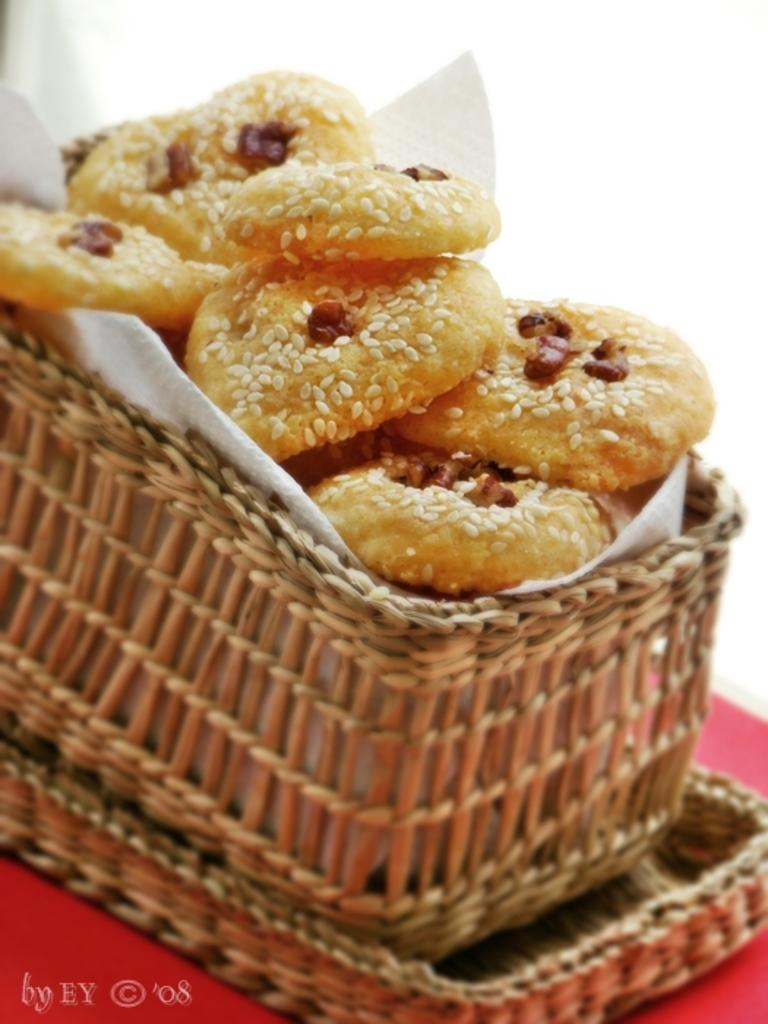What type of items can be seen in the image? There is food and a tissue in the image. Where are the food and tissue located? They are in a basket. What is the color of the object the basket is on? The basket is on a red object. What is the background color in the image? The background is white. What type of vest can be seen in the image? There is no vest present in the image. How many pies are visible in the image? There is no pie present in the image; it contains food, but the specific type is not mentioned. 